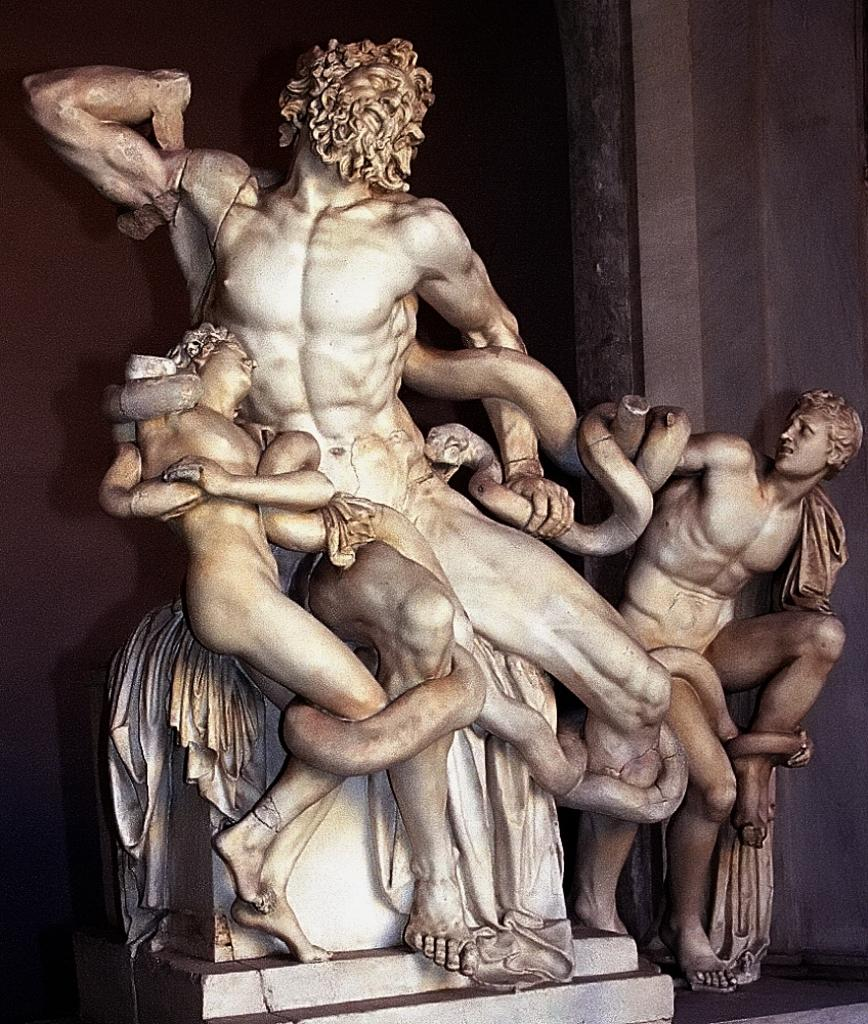What is the main subject of the image? The main subject of the image is a sculpture of some persons. Can you describe the sculpture in more detail? In the sculpture, a person is holding a snake in his hands. What type of coil is being used by the person in the sculpture? There is no coil present in the image; the person is holding a snake in his hands. Can you hear the snake in the image? The image is a still representation, so it is not possible to hear the snake or any sounds. 